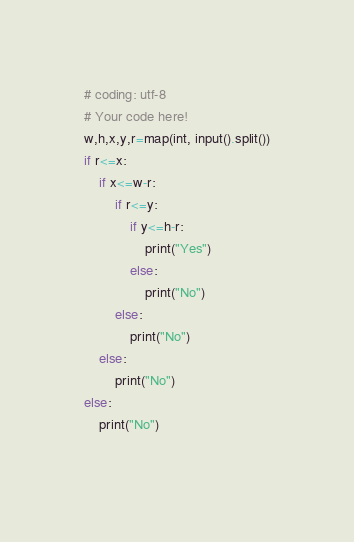Convert code to text. <code><loc_0><loc_0><loc_500><loc_500><_Python_># coding: utf-8
# Your code here!
w,h,x,y,r=map(int, input().split())
if r<=x:
    if x<=w-r:
        if r<=y:
            if y<=h-r:
                print("Yes")
            else:
                print("No")
        else:
            print("No")
    else:
        print("No")
else:
    print("No")
        

</code> 